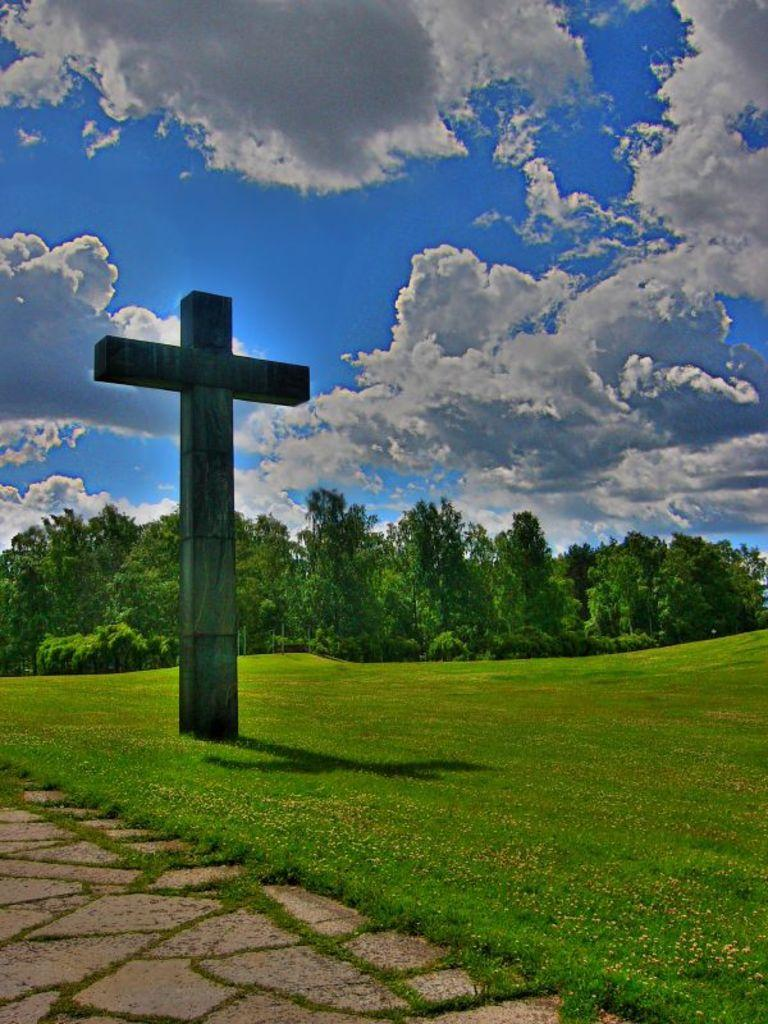What is the main subject of the image? There is a cross statue in the image. What type of ground is visible in the image? There is grass on the ground in the image. What can be seen in the background of the image? There are trees in the background of the image. What is visible at the top of the image? The sky is visible at the top of the image. What is the condition of the sky in the image? Clouds are present in the sky. Can you tell me how deep the river is in the image? There is no river present in the image; it features a cross statue, grass, trees, and a cloudy sky. What thoughts are going through the mind of the cross statue in the image? The cross statue is an inanimate object and does not have thoughts or a mind. 